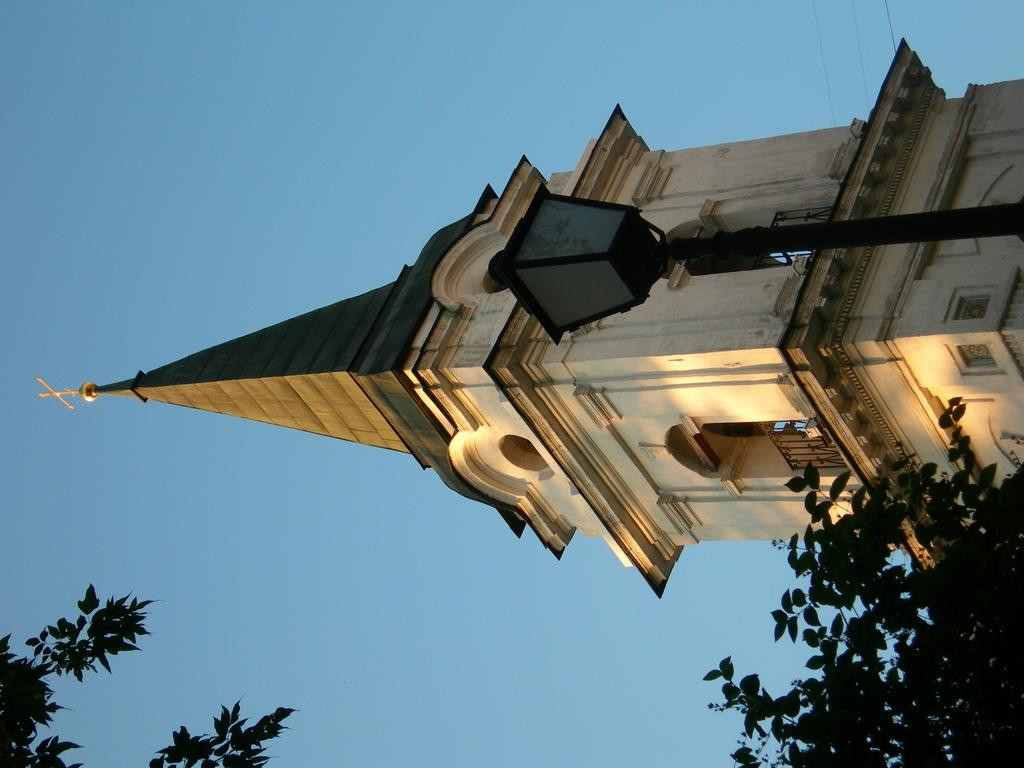What is the main structure in the image? There is a building in the image. What feature can be seen on the building? The building has windows. What type of vegetation is present in the image? There are trees in the image. What is visible in the background of the image? The sky is visible in the image. How many fangs can be seen on the trees in the image? There are no fangs present on the trees in the image; they are natural vegetation. What type of lead is used to construct the building in the image? The provided facts do not mention the materials used to construct the building, so it cannot be determined from the image. 